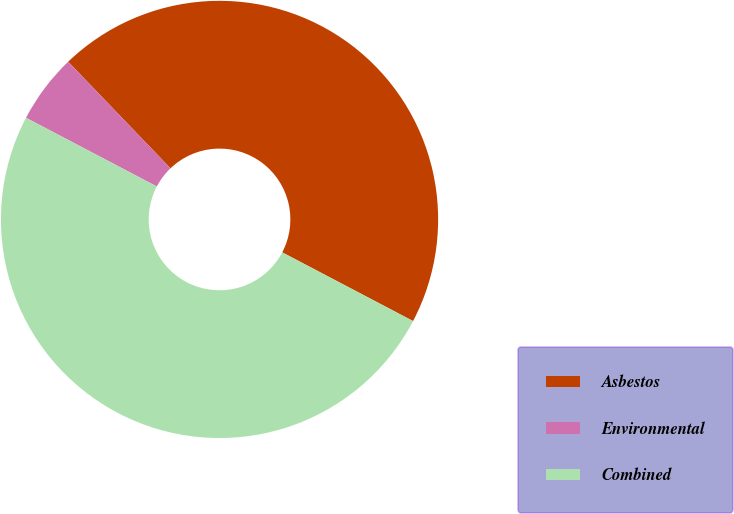<chart> <loc_0><loc_0><loc_500><loc_500><pie_chart><fcel>Asbestos<fcel>Environmental<fcel>Combined<nl><fcel>44.87%<fcel>5.13%<fcel>50.0%<nl></chart> 